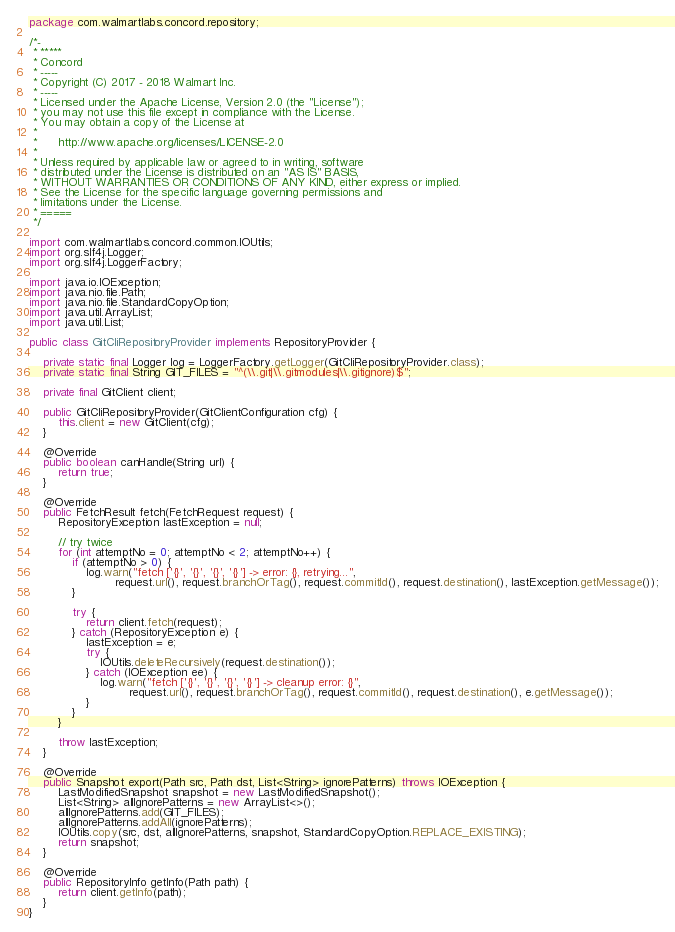<code> <loc_0><loc_0><loc_500><loc_500><_Java_>package com.walmartlabs.concord.repository;

/*-
 * *****
 * Concord
 * -----
 * Copyright (C) 2017 - 2018 Walmart Inc.
 * -----
 * Licensed under the Apache License, Version 2.0 (the "License");
 * you may not use this file except in compliance with the License.
 * You may obtain a copy of the License at
 *
 *      http://www.apache.org/licenses/LICENSE-2.0
 *
 * Unless required by applicable law or agreed to in writing, software
 * distributed under the License is distributed on an "AS IS" BASIS,
 * WITHOUT WARRANTIES OR CONDITIONS OF ANY KIND, either express or implied.
 * See the License for the specific language governing permissions and
 * limitations under the License.
 * =====
 */

import com.walmartlabs.concord.common.IOUtils;
import org.slf4j.Logger;
import org.slf4j.LoggerFactory;

import java.io.IOException;
import java.nio.file.Path;
import java.nio.file.StandardCopyOption;
import java.util.ArrayList;
import java.util.List;

public class GitCliRepositoryProvider implements RepositoryProvider {

    private static final Logger log = LoggerFactory.getLogger(GitCliRepositoryProvider.class);
    private static final String GIT_FILES = "^(\\.git|\\.gitmodules|\\.gitignore)$";

    private final GitClient client;

    public GitCliRepositoryProvider(GitClientConfiguration cfg) {
        this.client = new GitClient(cfg);
    }

    @Override
    public boolean canHandle(String url) {
        return true;
    }

    @Override
    public FetchResult fetch(FetchRequest request) {
        RepositoryException lastException = null;

        // try twice
        for (int attemptNo = 0; attemptNo < 2; attemptNo++) {
            if (attemptNo > 0) {
                log.warn("fetch ['{}', '{}', '{}', '{}'] -> error: {}, retrying...",
                        request.url(), request.branchOrTag(), request.commitId(), request.destination(), lastException.getMessage());
            }

            try {
                return client.fetch(request);
            } catch (RepositoryException e) {
                lastException = e;
                try {
                    IOUtils.deleteRecursively(request.destination());
                } catch (IOException ee) {
                    log.warn("fetch ['{}', '{}', '{}', '{}'] -> cleanup error: {}",
                            request.url(), request.branchOrTag(), request.commitId(), request.destination(), e.getMessage());
                }
            }
        }

        throw lastException;
    }

    @Override
    public Snapshot export(Path src, Path dst, List<String> ignorePatterns) throws IOException {
        LastModifiedSnapshot snapshot = new LastModifiedSnapshot();
        List<String> allIgnorePatterns = new ArrayList<>();
        allIgnorePatterns.add(GIT_FILES);
        allIgnorePatterns.addAll(ignorePatterns);
        IOUtils.copy(src, dst, allIgnorePatterns, snapshot, StandardCopyOption.REPLACE_EXISTING);
        return snapshot;
    }

    @Override
    public RepositoryInfo getInfo(Path path) {
        return client.getInfo(path);
    }
}
</code> 